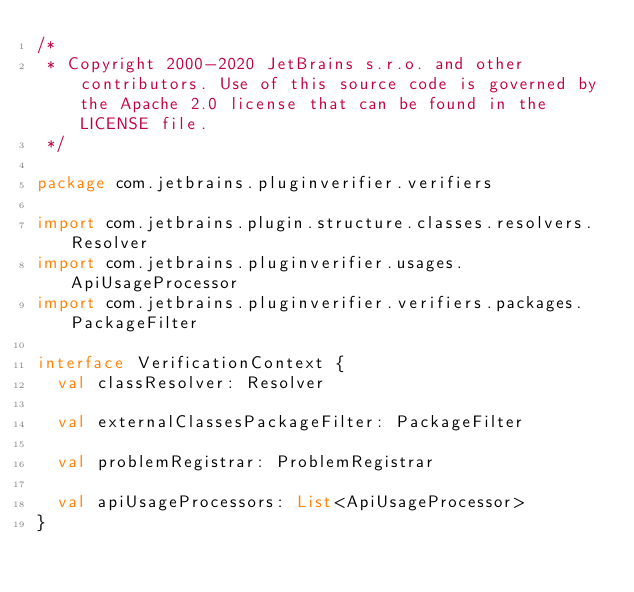Convert code to text. <code><loc_0><loc_0><loc_500><loc_500><_Kotlin_>/*
 * Copyright 2000-2020 JetBrains s.r.o. and other contributors. Use of this source code is governed by the Apache 2.0 license that can be found in the LICENSE file.
 */

package com.jetbrains.pluginverifier.verifiers

import com.jetbrains.plugin.structure.classes.resolvers.Resolver
import com.jetbrains.pluginverifier.usages.ApiUsageProcessor
import com.jetbrains.pluginverifier.verifiers.packages.PackageFilter

interface VerificationContext {
  val classResolver: Resolver

  val externalClassesPackageFilter: PackageFilter

  val problemRegistrar: ProblemRegistrar

  val apiUsageProcessors: List<ApiUsageProcessor>
}</code> 